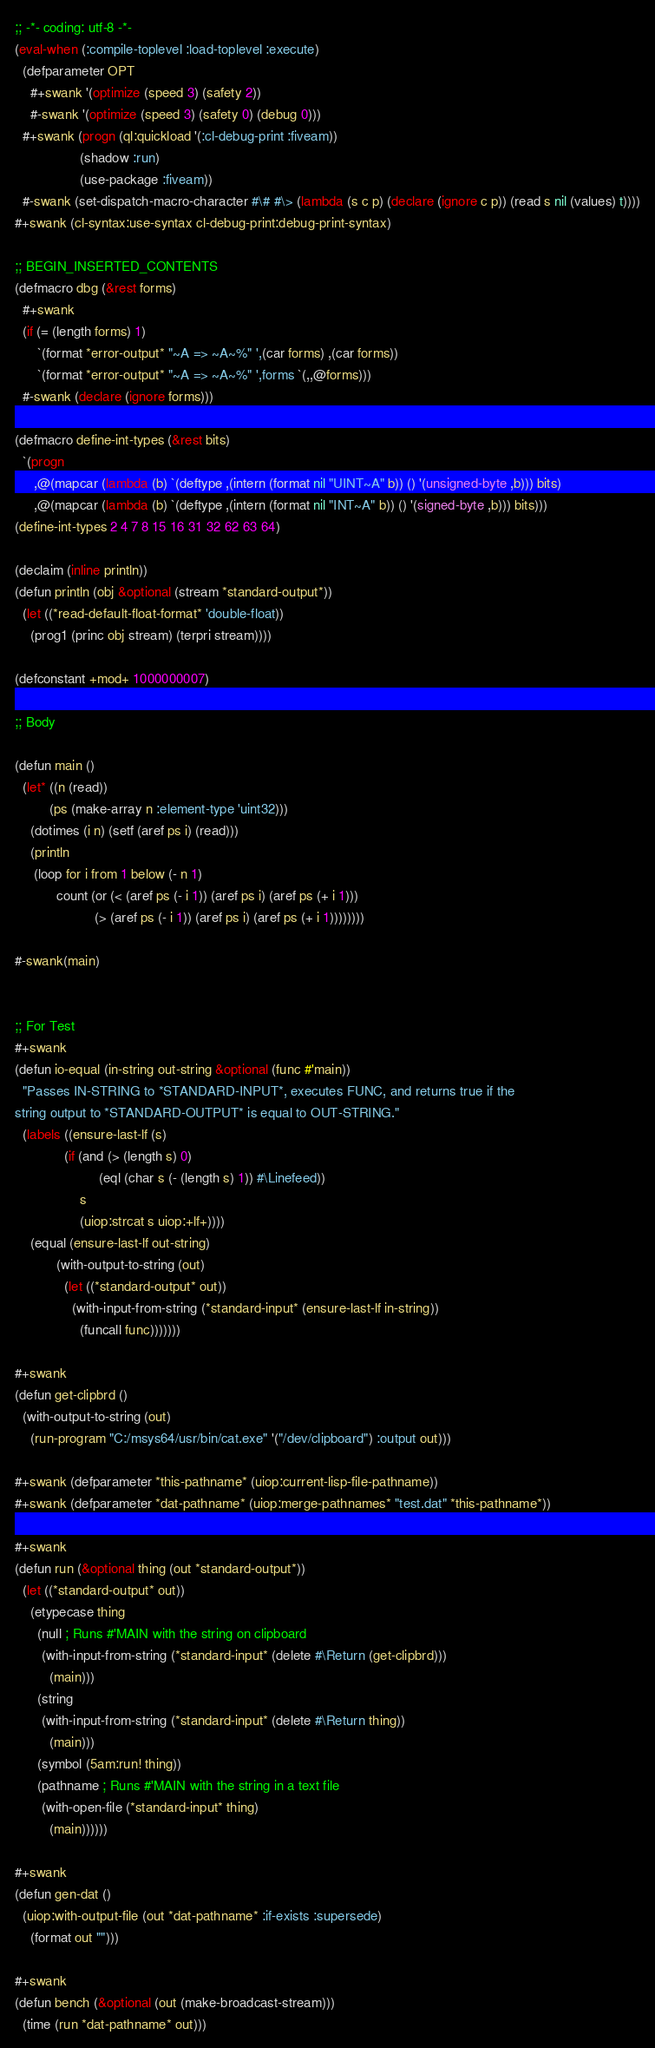<code> <loc_0><loc_0><loc_500><loc_500><_Lisp_>;; -*- coding: utf-8 -*-
(eval-when (:compile-toplevel :load-toplevel :execute)
  (defparameter OPT
    #+swank '(optimize (speed 3) (safety 2))
    #-swank '(optimize (speed 3) (safety 0) (debug 0)))
  #+swank (progn (ql:quickload '(:cl-debug-print :fiveam))
                 (shadow :run)
                 (use-package :fiveam))
  #-swank (set-dispatch-macro-character #\# #\> (lambda (s c p) (declare (ignore c p)) (read s nil (values) t))))
#+swank (cl-syntax:use-syntax cl-debug-print:debug-print-syntax)

;; BEGIN_INSERTED_CONTENTS
(defmacro dbg (&rest forms)
  #+swank
  (if (= (length forms) 1)
      `(format *error-output* "~A => ~A~%" ',(car forms) ,(car forms))
      `(format *error-output* "~A => ~A~%" ',forms `(,,@forms)))
  #-swank (declare (ignore forms)))

(defmacro define-int-types (&rest bits)
  `(progn
     ,@(mapcar (lambda (b) `(deftype ,(intern (format nil "UINT~A" b)) () '(unsigned-byte ,b))) bits)
     ,@(mapcar (lambda (b) `(deftype ,(intern (format nil "INT~A" b)) () '(signed-byte ,b))) bits)))
(define-int-types 2 4 7 8 15 16 31 32 62 63 64)

(declaim (inline println))
(defun println (obj &optional (stream *standard-output*))
  (let ((*read-default-float-format* 'double-float))
    (prog1 (princ obj stream) (terpri stream))))

(defconstant +mod+ 1000000007)

;; Body

(defun main ()
  (let* ((n (read))
         (ps (make-array n :element-type 'uint32)))
    (dotimes (i n) (setf (aref ps i) (read)))
    (println
     (loop for i from 1 below (- n 1)
           count (or (< (aref ps (- i 1)) (aref ps i) (aref ps (+ i 1)))
                     (> (aref ps (- i 1)) (aref ps i) (aref ps (+ i 1))))))))

#-swank(main)


;; For Test
#+swank
(defun io-equal (in-string out-string &optional (func #'main))
  "Passes IN-STRING to *STANDARD-INPUT*, executes FUNC, and returns true if the
string output to *STANDARD-OUTPUT* is equal to OUT-STRING."
  (labels ((ensure-last-lf (s)
             (if (and (> (length s) 0)
                      (eql (char s (- (length s) 1)) #\Linefeed))
                 s
                 (uiop:strcat s uiop:+lf+))))
    (equal (ensure-last-lf out-string)
           (with-output-to-string (out)
             (let ((*standard-output* out))
               (with-input-from-string (*standard-input* (ensure-last-lf in-string))
                 (funcall func)))))))

#+swank
(defun get-clipbrd ()
  (with-output-to-string (out)
    (run-program "C:/msys64/usr/bin/cat.exe" '("/dev/clipboard") :output out)))

#+swank (defparameter *this-pathname* (uiop:current-lisp-file-pathname))
#+swank (defparameter *dat-pathname* (uiop:merge-pathnames* "test.dat" *this-pathname*))

#+swank
(defun run (&optional thing (out *standard-output*))
  (let ((*standard-output* out))
    (etypecase thing
      (null ; Runs #'MAIN with the string on clipboard
       (with-input-from-string (*standard-input* (delete #\Return (get-clipbrd)))
         (main)))
      (string
       (with-input-from-string (*standard-input* (delete #\Return thing))
         (main)))
      (symbol (5am:run! thing))
      (pathname ; Runs #'MAIN with the string in a text file
       (with-open-file (*standard-input* thing)
         (main))))))

#+swank
(defun gen-dat ()
  (uiop:with-output-file (out *dat-pathname* :if-exists :supersede)
    (format out "")))

#+swank
(defun bench (&optional (out (make-broadcast-stream)))
  (time (run *dat-pathname* out)))
</code> 